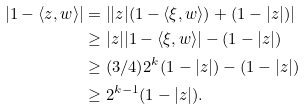<formula> <loc_0><loc_0><loc_500><loc_500>| 1 - \langle z , w \rangle | & = \left | | z | ( 1 - \langle \xi , w \rangle ) + ( 1 - | z | ) \right | \\ & \geq | z | | 1 - \langle \xi , w \rangle | - ( 1 - | z | ) \\ & \geq ( 3 / 4 ) 2 ^ { k } ( 1 - | z | ) - ( 1 - | z | ) \\ & \geq 2 ^ { k - 1 } ( 1 - | z | ) .</formula> 